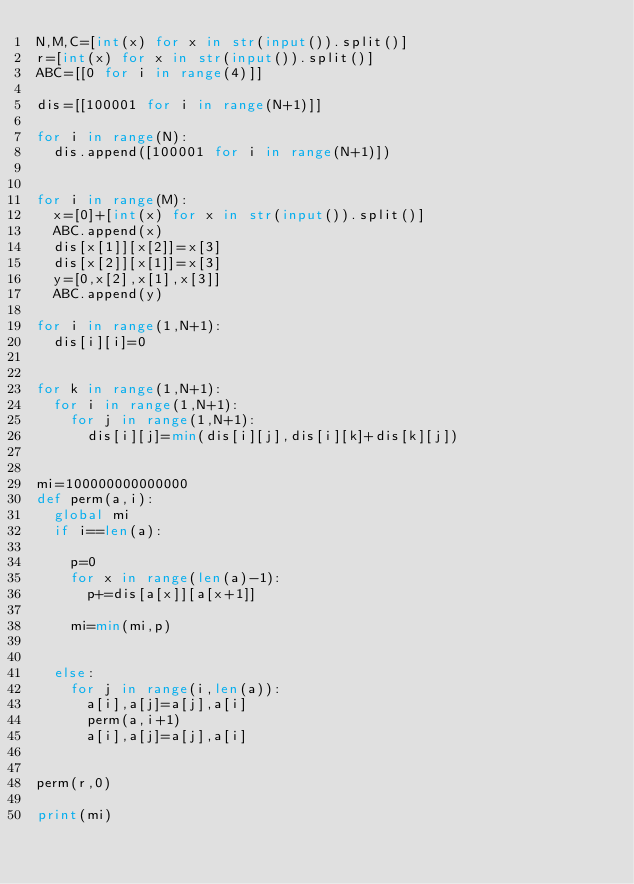<code> <loc_0><loc_0><loc_500><loc_500><_Python_>N,M,C=[int(x) for x in str(input()).split()]
r=[int(x) for x in str(input()).split()]
ABC=[[0 for i in range(4)]]

dis=[[100001 for i in range(N+1)]]

for i in range(N):
  dis.append([100001 for i in range(N+1)])


for i in range(M):
  x=[0]+[int(x) for x in str(input()).split()]
  ABC.append(x)
  dis[x[1]][x[2]]=x[3]
  dis[x[2]][x[1]]=x[3]
  y=[0,x[2],x[1],x[3]]
  ABC.append(y)

for i in range(1,N+1):
  dis[i][i]=0


for k in range(1,N+1):
  for i in range(1,N+1):
    for j in range(1,N+1):
      dis[i][j]=min(dis[i][j],dis[i][k]+dis[k][j])


mi=100000000000000
def perm(a,i):
  global mi
  if i==len(a):      

    p=0
    for x in range(len(a)-1):
      p+=dis[a[x]][a[x+1]]

    mi=min(mi,p)


  else:
    for j in range(i,len(a)):
      a[i],a[j]=a[j],a[i]
      perm(a,i+1)
      a[i],a[j]=a[j],a[i]


perm(r,0)

print(mi)</code> 